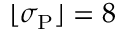Convert formula to latex. <formula><loc_0><loc_0><loc_500><loc_500>\lfloor \sigma _ { P } \rfloor = 8</formula> 